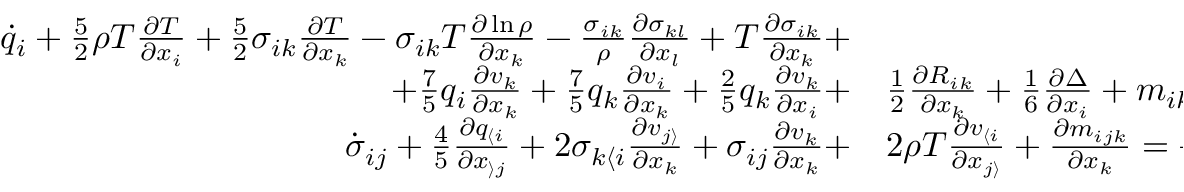Convert formula to latex. <formula><loc_0><loc_0><loc_500><loc_500>\begin{array} { r l } { \dot { q } _ { i } + \frac { 5 } { 2 } \rho T \frac { \partial T } { \partial x _ { i } } + \frac { 5 } { 2 } \sigma _ { i k } \frac { \partial T } { \partial x _ { k } } - \sigma _ { i k } T \frac { \partial \ln \rho } { \partial x _ { k } } - \frac { \sigma _ { i k } } { \rho } \frac { \partial \sigma _ { k l } } { \partial x _ { l } } + T \frac { \partial \sigma _ { i k } } { \partial x _ { k } } + } \\ { + \frac { 7 } { 5 } q _ { i } \frac { \partial v _ { k } } { \partial x _ { k } } + \frac { 7 } { 5 } q _ { k } \frac { \partial v _ { i } } { \partial x _ { k } } + \frac { 2 } { 5 } q _ { k } \frac { \partial v _ { k } } { \partial x _ { i } } + } & \frac { 1 } { 2 } \frac { \partial R _ { i k } } { \partial x _ { k } } + \frac { 1 } { 6 } \frac { \partial \Delta } { \partial x _ { i } } + m _ { i k l } \frac { \partial v _ { k } } { \partial x _ { l } } = - \frac { 2 } { 3 } \frac { p } { \mu } q _ { i } , } \\ { \dot { \sigma } _ { i j } + \frac { 4 } { 5 } \frac { \partial q _ { \langle i } } { \partial x _ { \rangle j } } + 2 \sigma _ { k \langle i } \frac { \partial v _ { j \rangle } } { \partial x _ { k } } + \sigma _ { i j } \frac { \partial v _ { k } } { \partial x _ { k } } + } & 2 \rho T \frac { \partial v _ { \langle i } } { \partial x _ { j \rangle } } + \frac { \partial m _ { i j k } } { \partial x _ { k } } = - \frac { p } { \mu } \sigma _ { i j } , } \end{array}</formula> 